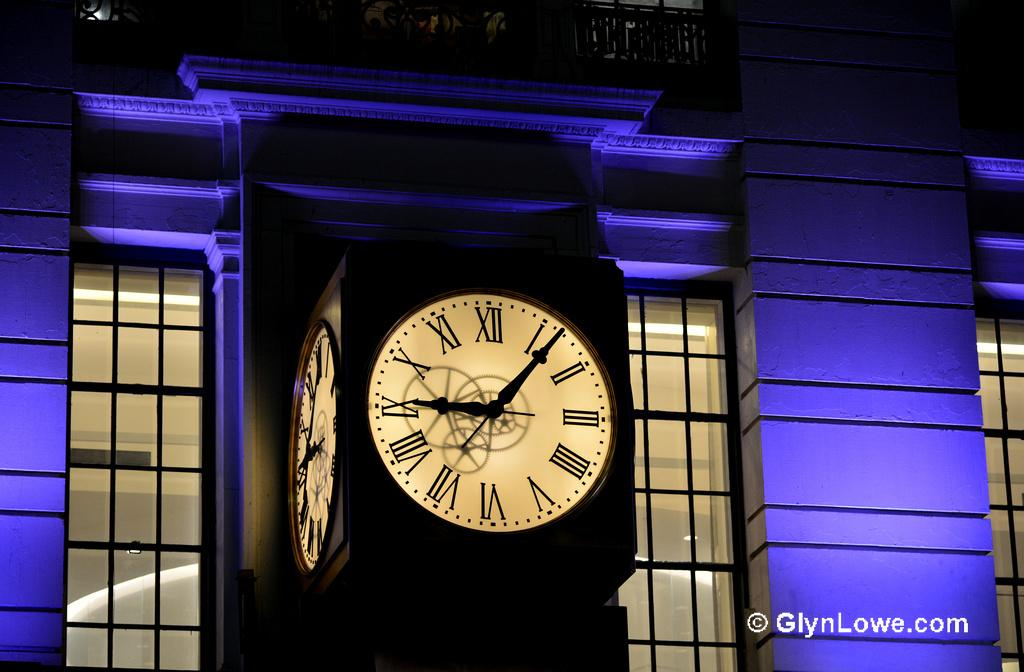<image>
Offer a succinct explanation of the picture presented. A photo from GlynLowe.com shows a clocktower at night. 